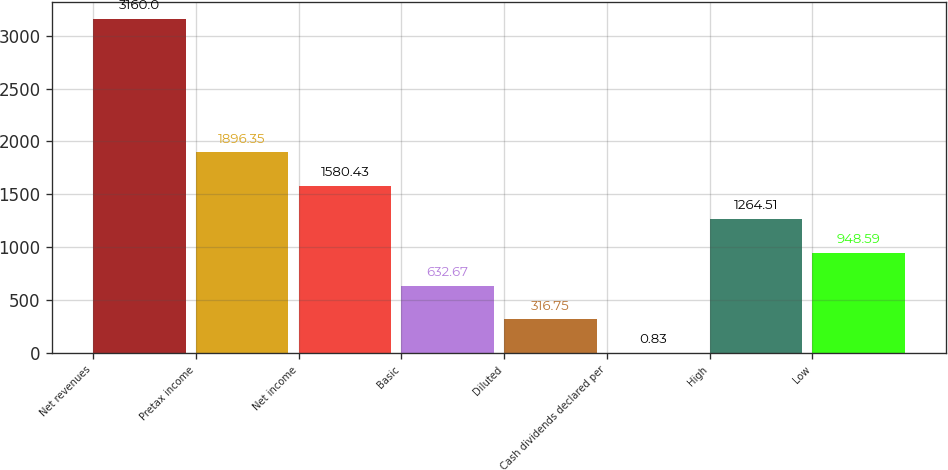<chart> <loc_0><loc_0><loc_500><loc_500><bar_chart><fcel>Net revenues<fcel>Pretax income<fcel>Net income<fcel>Basic<fcel>Diluted<fcel>Cash dividends declared per<fcel>High<fcel>Low<nl><fcel>3160<fcel>1896.35<fcel>1580.43<fcel>632.67<fcel>316.75<fcel>0.83<fcel>1264.51<fcel>948.59<nl></chart> 